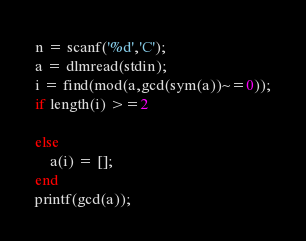Convert code to text. <code><loc_0><loc_0><loc_500><loc_500><_Octave_>n = scanf('%d','C');
a = dlmread(stdin);
i = find(mod(a,gcd(sym(a))~=0));
if length(i) >=2

else
	a(i) = [];
end
printf(gcd(a));
</code> 